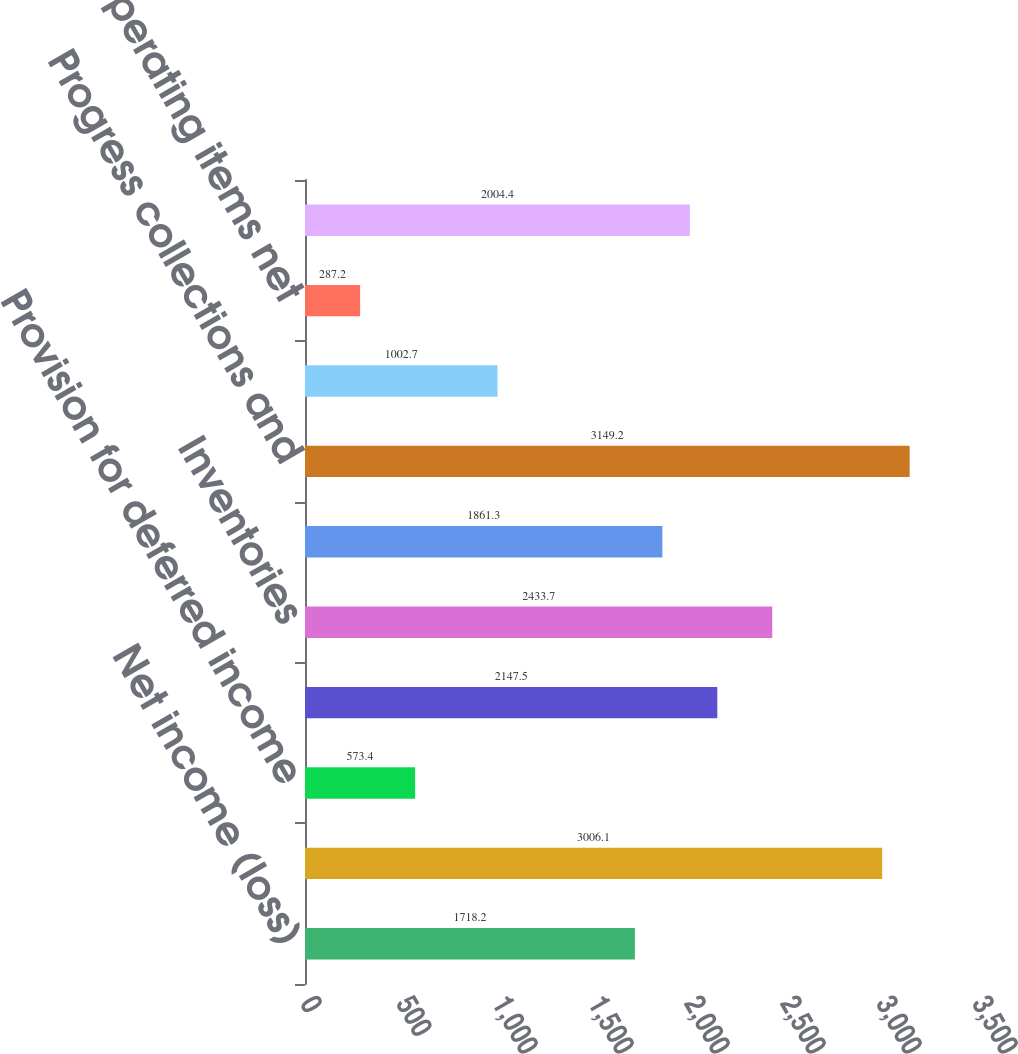Convert chart to OTSL. <chart><loc_0><loc_0><loc_500><loc_500><bar_chart><fcel>Net income (loss)<fcel>Depreciation and amortization<fcel>Provision for deferred income<fcel>Current receivables<fcel>Inventories<fcel>Accounts payable<fcel>Progress collections and<fcel>Contract and other deferred<fcel>Other operating items net<fcel>Net cash flows from (used in)<nl><fcel>1718.2<fcel>3006.1<fcel>573.4<fcel>2147.5<fcel>2433.7<fcel>1861.3<fcel>3149.2<fcel>1002.7<fcel>287.2<fcel>2004.4<nl></chart> 